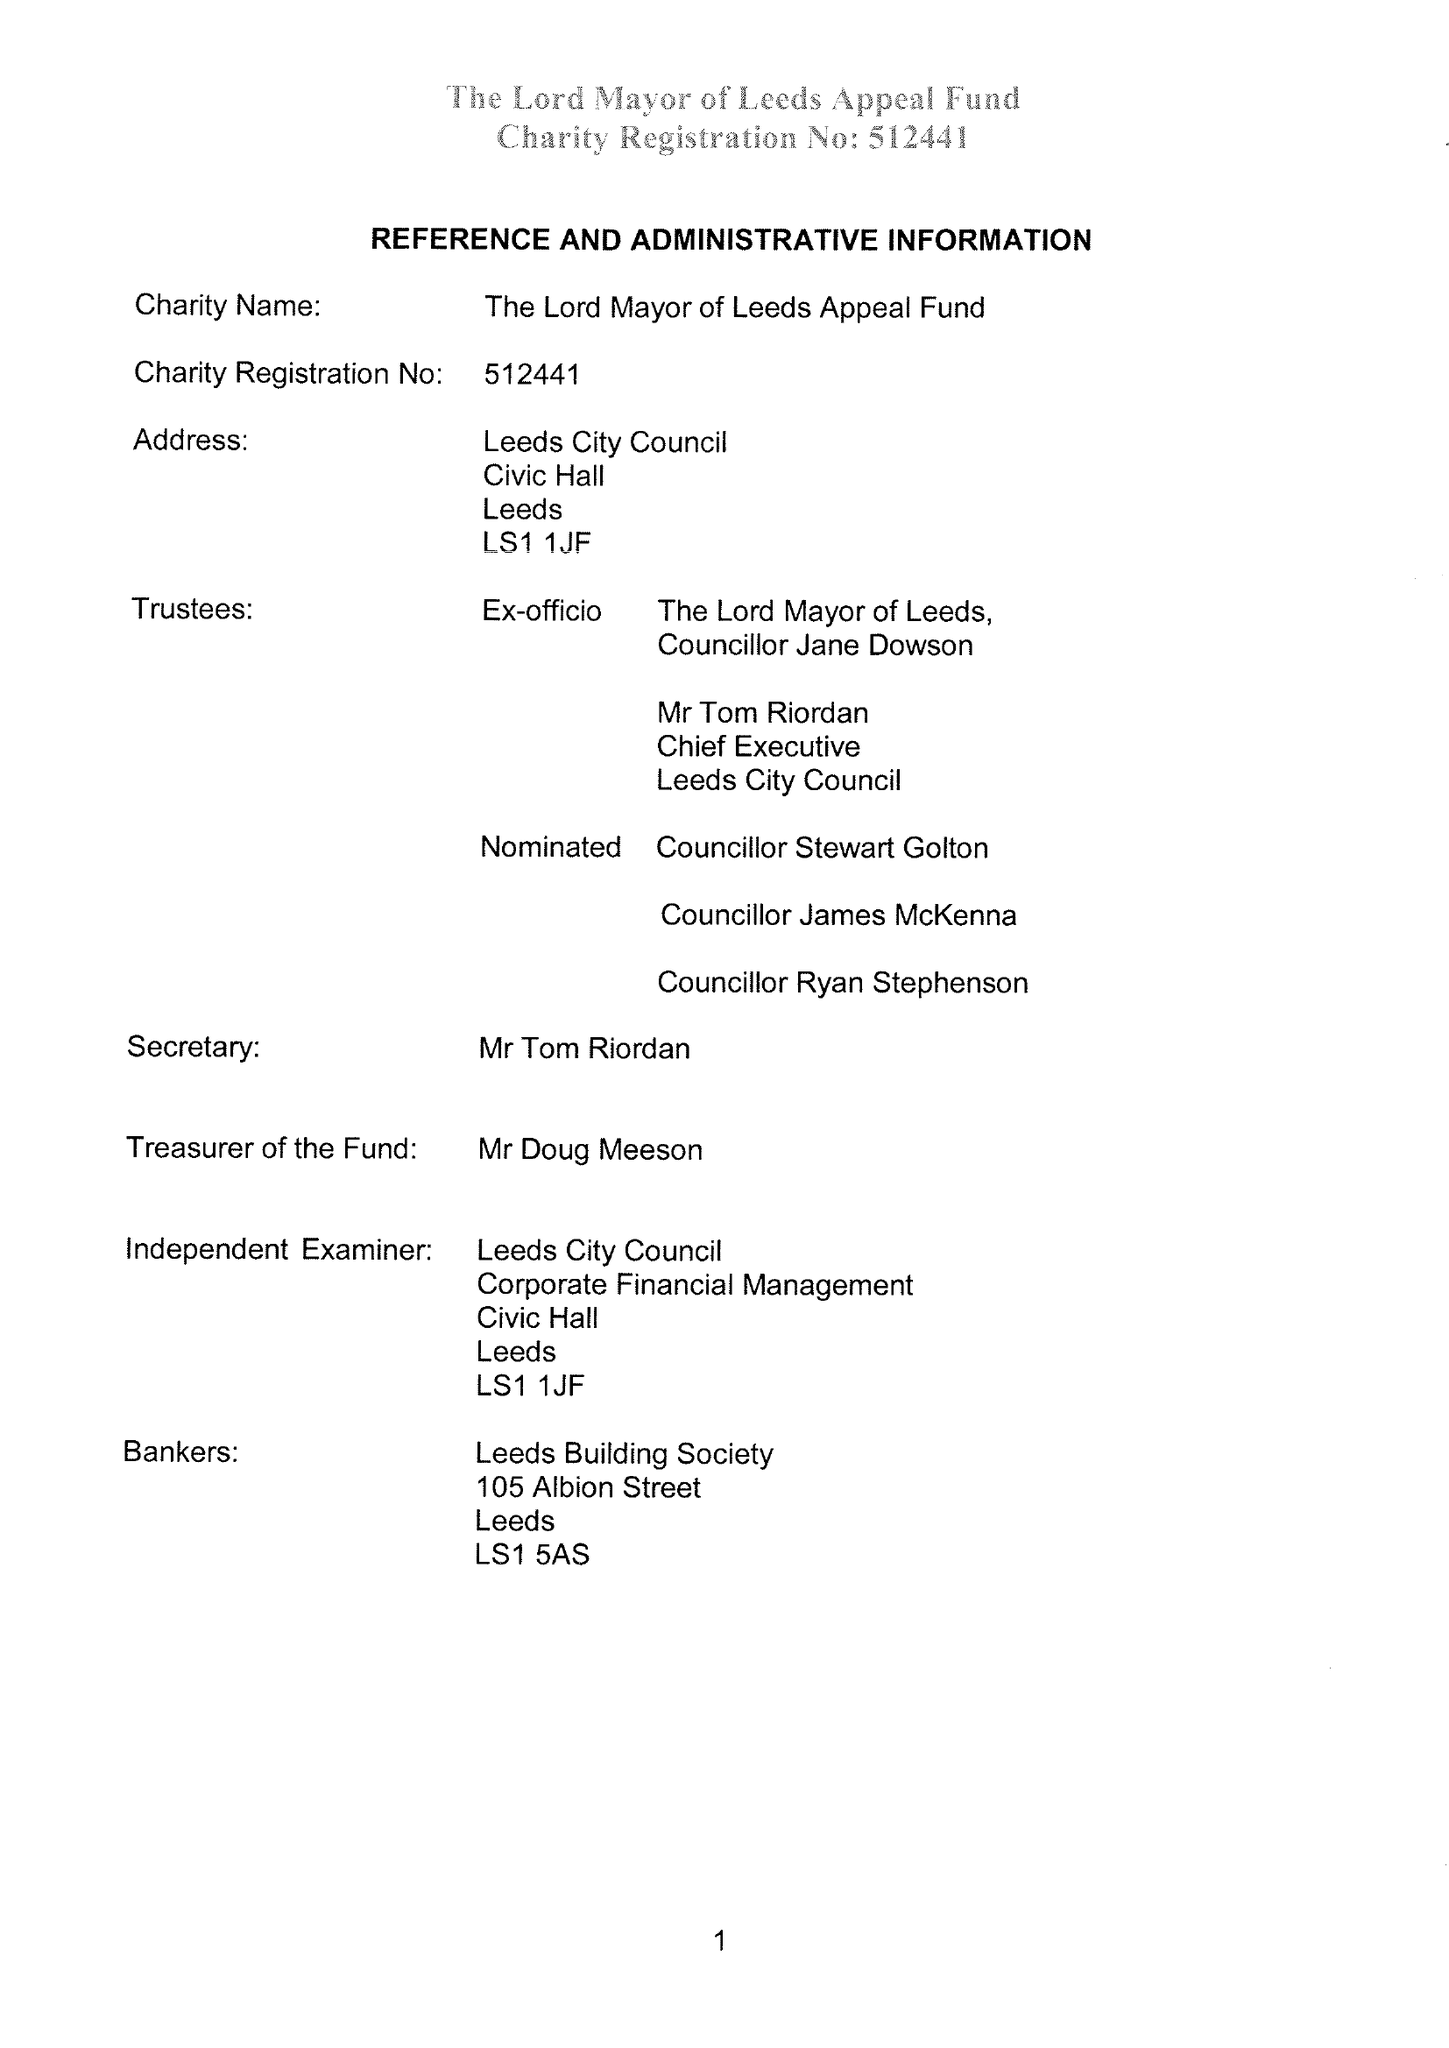What is the value for the charity_name?
Answer the question using a single word or phrase. Lord Mayor Of Leeds Appeal Fund 